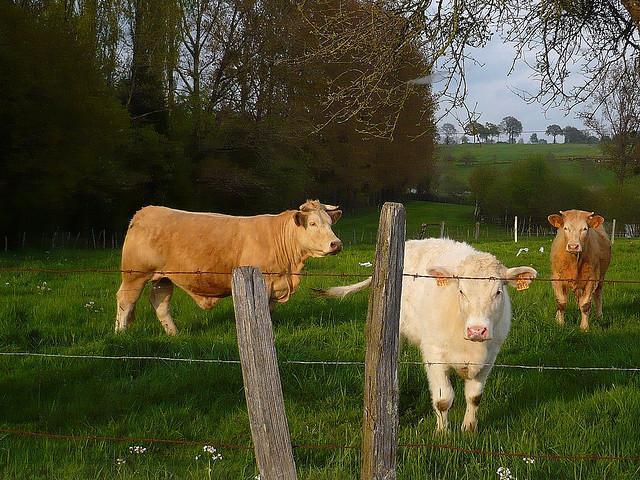How many cows are there?
Give a very brief answer. 3. How many cows are standing in this field?
Give a very brief answer. 3. 